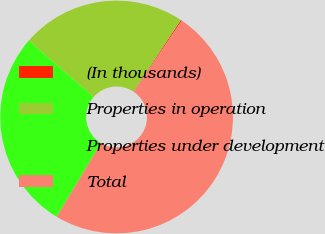Convert chart to OTSL. <chart><loc_0><loc_0><loc_500><loc_500><pie_chart><fcel>(In thousands)<fcel>Properties in operation<fcel>Properties under development<fcel>Total<nl><fcel>0.16%<fcel>22.91%<fcel>27.8%<fcel>49.13%<nl></chart> 